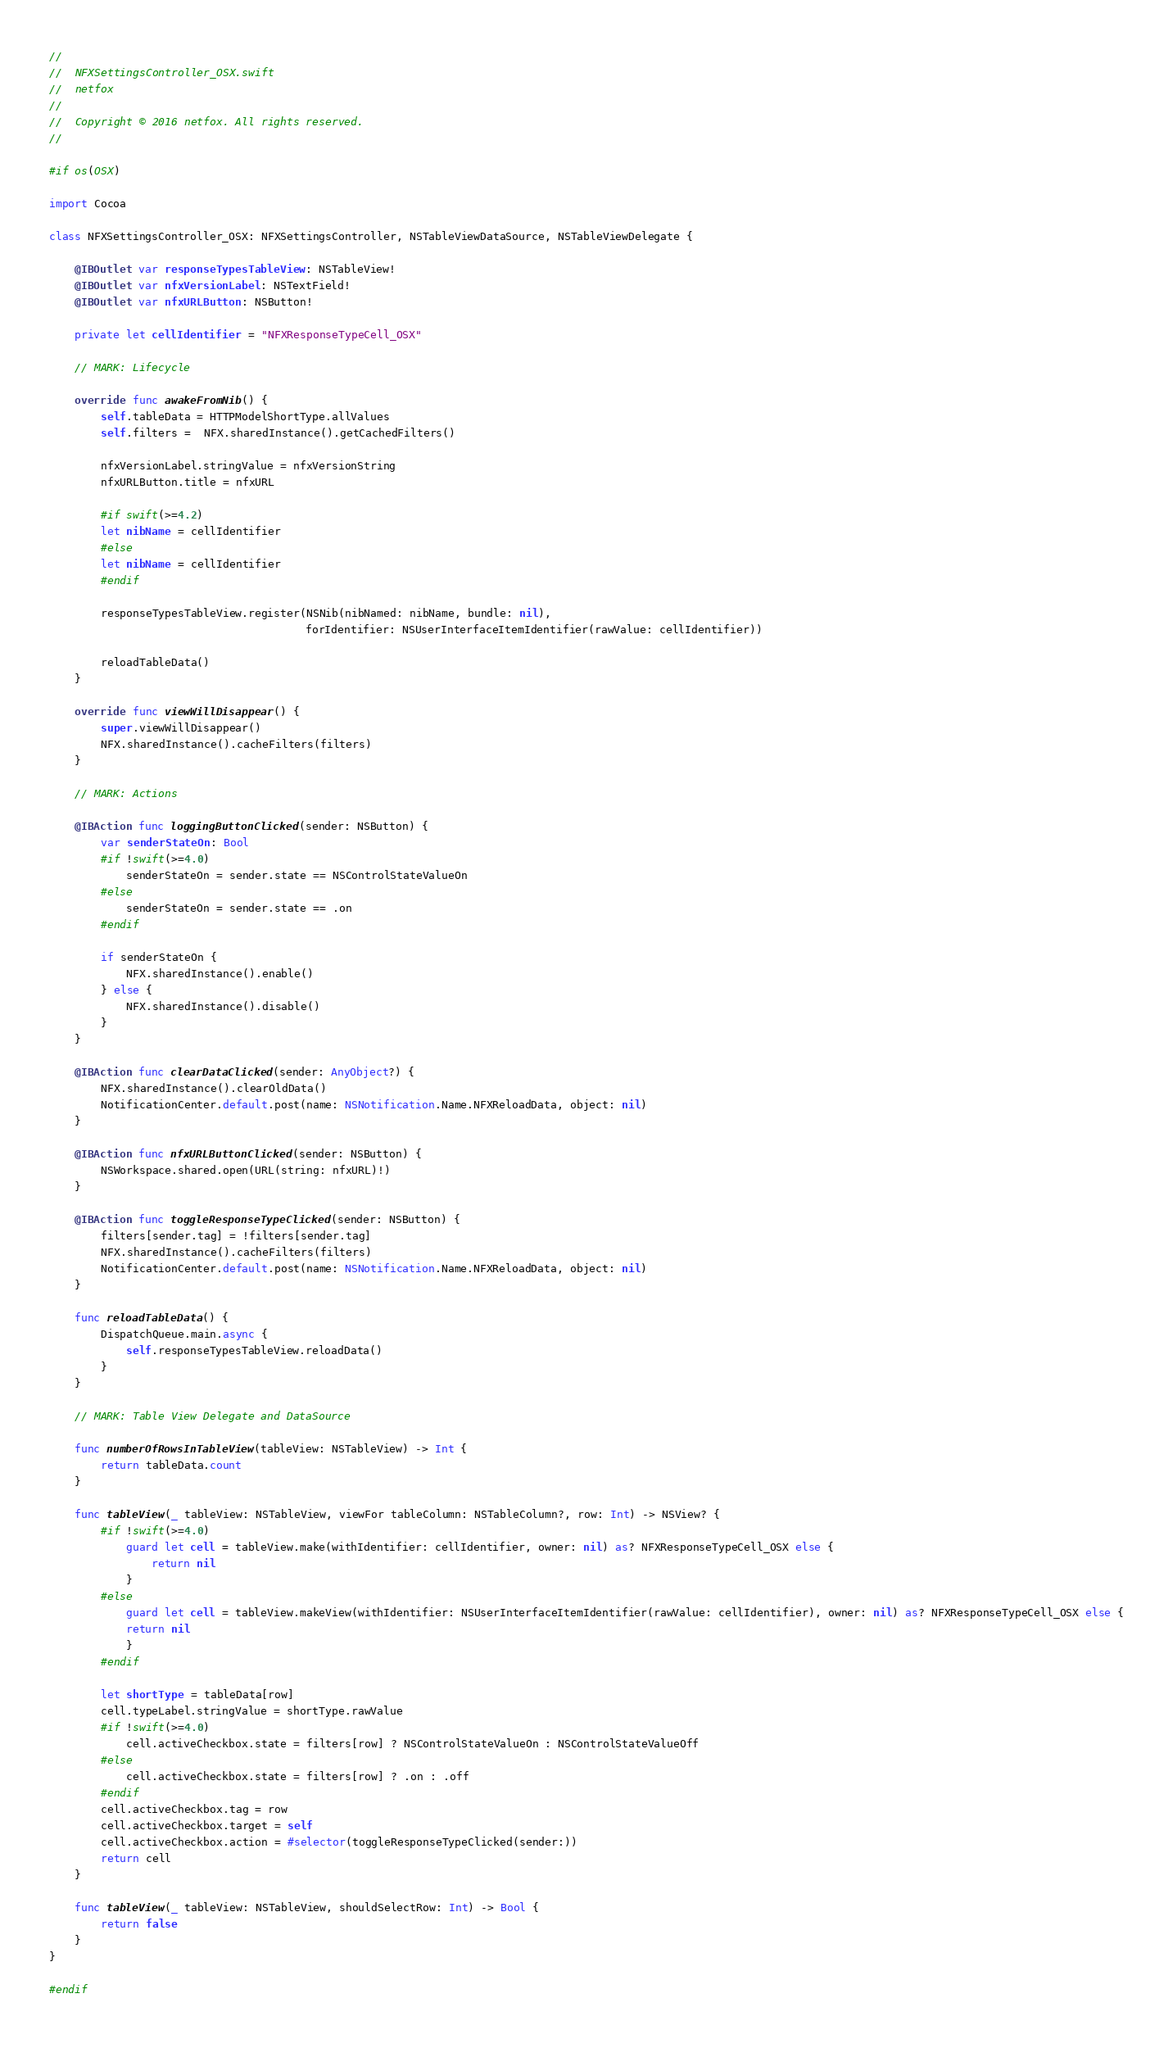Convert code to text. <code><loc_0><loc_0><loc_500><loc_500><_Swift_>//
//  NFXSettingsController_OSX.swift
//  netfox
//
//  Copyright © 2016 netfox. All rights reserved.
//

#if os(OSX)

import Cocoa
    
class NFXSettingsController_OSX: NFXSettingsController, NSTableViewDataSource, NSTableViewDelegate {
    
    @IBOutlet var responseTypesTableView: NSTableView!
    @IBOutlet var nfxVersionLabel: NSTextField!
    @IBOutlet var nfxURLButton: NSButton!
    
    private let cellIdentifier = "NFXResponseTypeCell_OSX"
    
    // MARK: Lifecycle
    
    override func awakeFromNib() {
        self.tableData = HTTPModelShortType.allValues
        self.filters =  NFX.sharedInstance().getCachedFilters()
        
        nfxVersionLabel.stringValue = nfxVersionString
        nfxURLButton.title = nfxURL

        #if swift(>=4.2)
        let nibName = cellIdentifier
        #else
        let nibName = cellIdentifier
        #endif

        responseTypesTableView.register(NSNib(nibNamed: nibName, bundle: nil),
                                        forIdentifier: NSUserInterfaceItemIdentifier(rawValue: cellIdentifier))
        
        reloadTableData()
    }
    
    override func viewWillDisappear() {
        super.viewWillDisappear()
        NFX.sharedInstance().cacheFilters(filters)
    }
    
    // MARK: Actions

    @IBAction func loggingButtonClicked(sender: NSButton) {
        var senderStateOn: Bool
        #if !swift(>=4.0)
            senderStateOn = sender.state == NSControlStateValueOn
        #else
            senderStateOn = sender.state == .on
        #endif
        
        if senderStateOn {
            NFX.sharedInstance().enable()
        } else {
            NFX.sharedInstance().disable()
        }
    }
    
    @IBAction func clearDataClicked(sender: AnyObject?) {
        NFX.sharedInstance().clearOldData()
        NotificationCenter.default.post(name: NSNotification.Name.NFXReloadData, object: nil)
    }
    
    @IBAction func nfxURLButtonClicked(sender: NSButton) {
        NSWorkspace.shared.open(URL(string: nfxURL)!)
    }
    
    @IBAction func toggleResponseTypeClicked(sender: NSButton) {
        filters[sender.tag] = !filters[sender.tag]
        NFX.sharedInstance().cacheFilters(filters)
        NotificationCenter.default.post(name: NSNotification.Name.NFXReloadData, object: nil)
    }
    
    func reloadTableData() {
        DispatchQueue.main.async {
            self.responseTypesTableView.reloadData()
        }
    }
    
    // MARK: Table View Delegate and DataSource
    
    func numberOfRowsInTableView(tableView: NSTableView) -> Int {
        return tableData.count
    }
    
    func tableView(_ tableView: NSTableView, viewFor tableColumn: NSTableColumn?, row: Int) -> NSView? {
        #if !swift(>=4.0)
            guard let cell = tableView.make(withIdentifier: cellIdentifier, owner: nil) as? NFXResponseTypeCell_OSX else {
                return nil
            }
        #else
            guard let cell = tableView.makeView(withIdentifier: NSUserInterfaceItemIdentifier(rawValue: cellIdentifier), owner: nil) as? NFXResponseTypeCell_OSX else {
            return nil
            }
        #endif
        
        let shortType = tableData[row]
        cell.typeLabel.stringValue = shortType.rawValue
        #if !swift(>=4.0)
            cell.activeCheckbox.state = filters[row] ? NSControlStateValueOn : NSControlStateValueOff
        #else
            cell.activeCheckbox.state = filters[row] ? .on : .off
        #endif
        cell.activeCheckbox.tag = row
        cell.activeCheckbox.target = self
        cell.activeCheckbox.action = #selector(toggleResponseTypeClicked(sender:))
        return cell
    }
    
    func tableView(_ tableView: NSTableView, shouldSelectRow: Int) -> Bool {
        return false
    }
}

#endif
</code> 